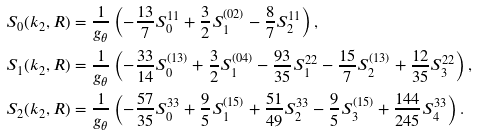Convert formula to latex. <formula><loc_0><loc_0><loc_500><loc_500>S _ { 0 } ( k _ { 2 } , R ) & = \frac { 1 } { g _ { \theta } } \left ( - \frac { 1 3 } { 7 } S ^ { 1 1 } _ { 0 } + \frac { 3 } { 2 } S ^ { ( 0 2 ) } _ { 1 } - \frac { 8 } { 7 } S ^ { 1 1 } _ { 2 } \right ) , \\ S _ { 1 } ( k _ { 2 } , R ) & = \frac { 1 } { g _ { \theta } } \left ( - \frac { 3 3 } { 1 4 } S ^ { ( 1 3 ) } _ { 0 } + \frac { 3 } { 2 } S ^ { ( 0 4 ) } _ { 1 } - \frac { 9 3 } { 3 5 } S ^ { 2 2 } _ { 1 } - \frac { 1 5 } { 7 } S ^ { ( 1 3 ) } _ { 2 } + \frac { 1 2 } { 3 5 } S ^ { 2 2 } _ { 3 } \right ) , \\ S _ { 2 } ( k _ { 2 } , R ) & = \frac { 1 } { g _ { \theta } } \left ( - \frac { 5 7 } { 3 5 } S ^ { 3 3 } _ { 0 } + \frac { 9 } { 5 } S ^ { ( 1 5 ) } _ { 1 } + \frac { 5 1 } { 4 9 } S ^ { 3 3 } _ { 2 } - \frac { 9 } { 5 } S ^ { ( 1 5 ) } _ { 3 } + \frac { 1 4 4 } { 2 4 5 } S ^ { 3 3 } _ { 4 } \right ) .</formula> 